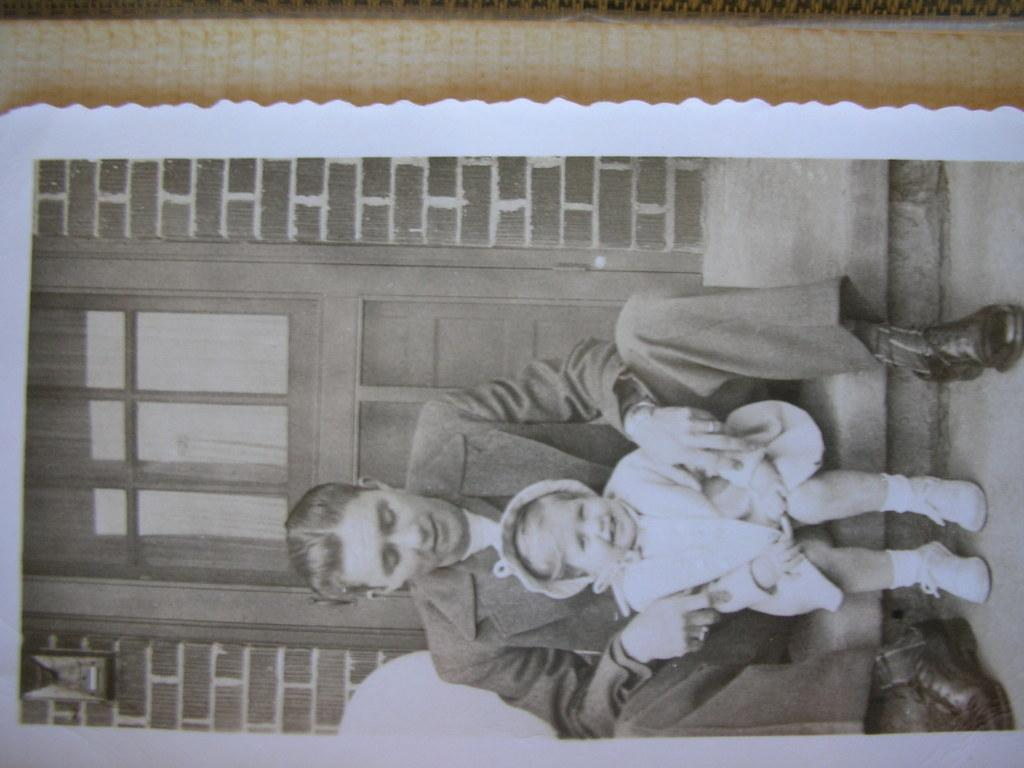What object is present in the image that typically holds a photo? There is a photo frame in the image. Who can be seen in the photo inside the frame? The photo contains a man and a kid. Where are the man and kid sitting in the image? The man and kid are sitting on a staircase. What type of wall is visible behind the man and kid? There is a brick wall behind the man and kid. Can you describe what is visible behind the brick wall? There is a door visible behind the brick wall. What type of eggs can be seen floating in the soda in the image? There are no eggs or soda present in the image; it features a photo frame with a photo of a man and a kid sitting on a staircase in front of a brick wall with a door visible behind it. 